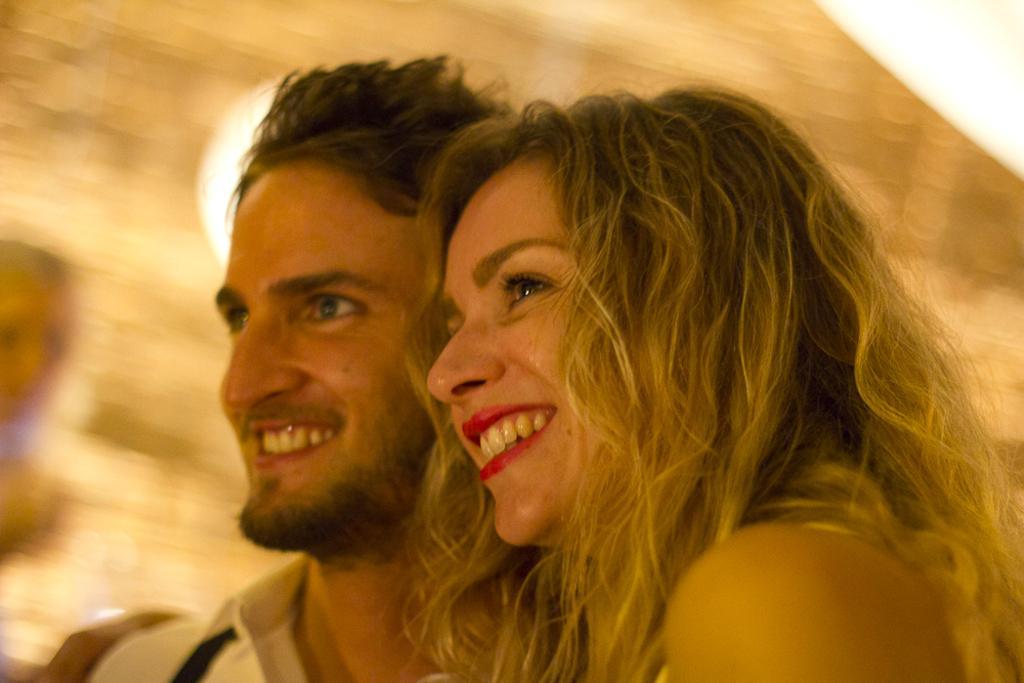Could you give a brief overview of what you see in this image? In this picture we can see a couple standing in the front and smiling. Behind we can see the blur background. 